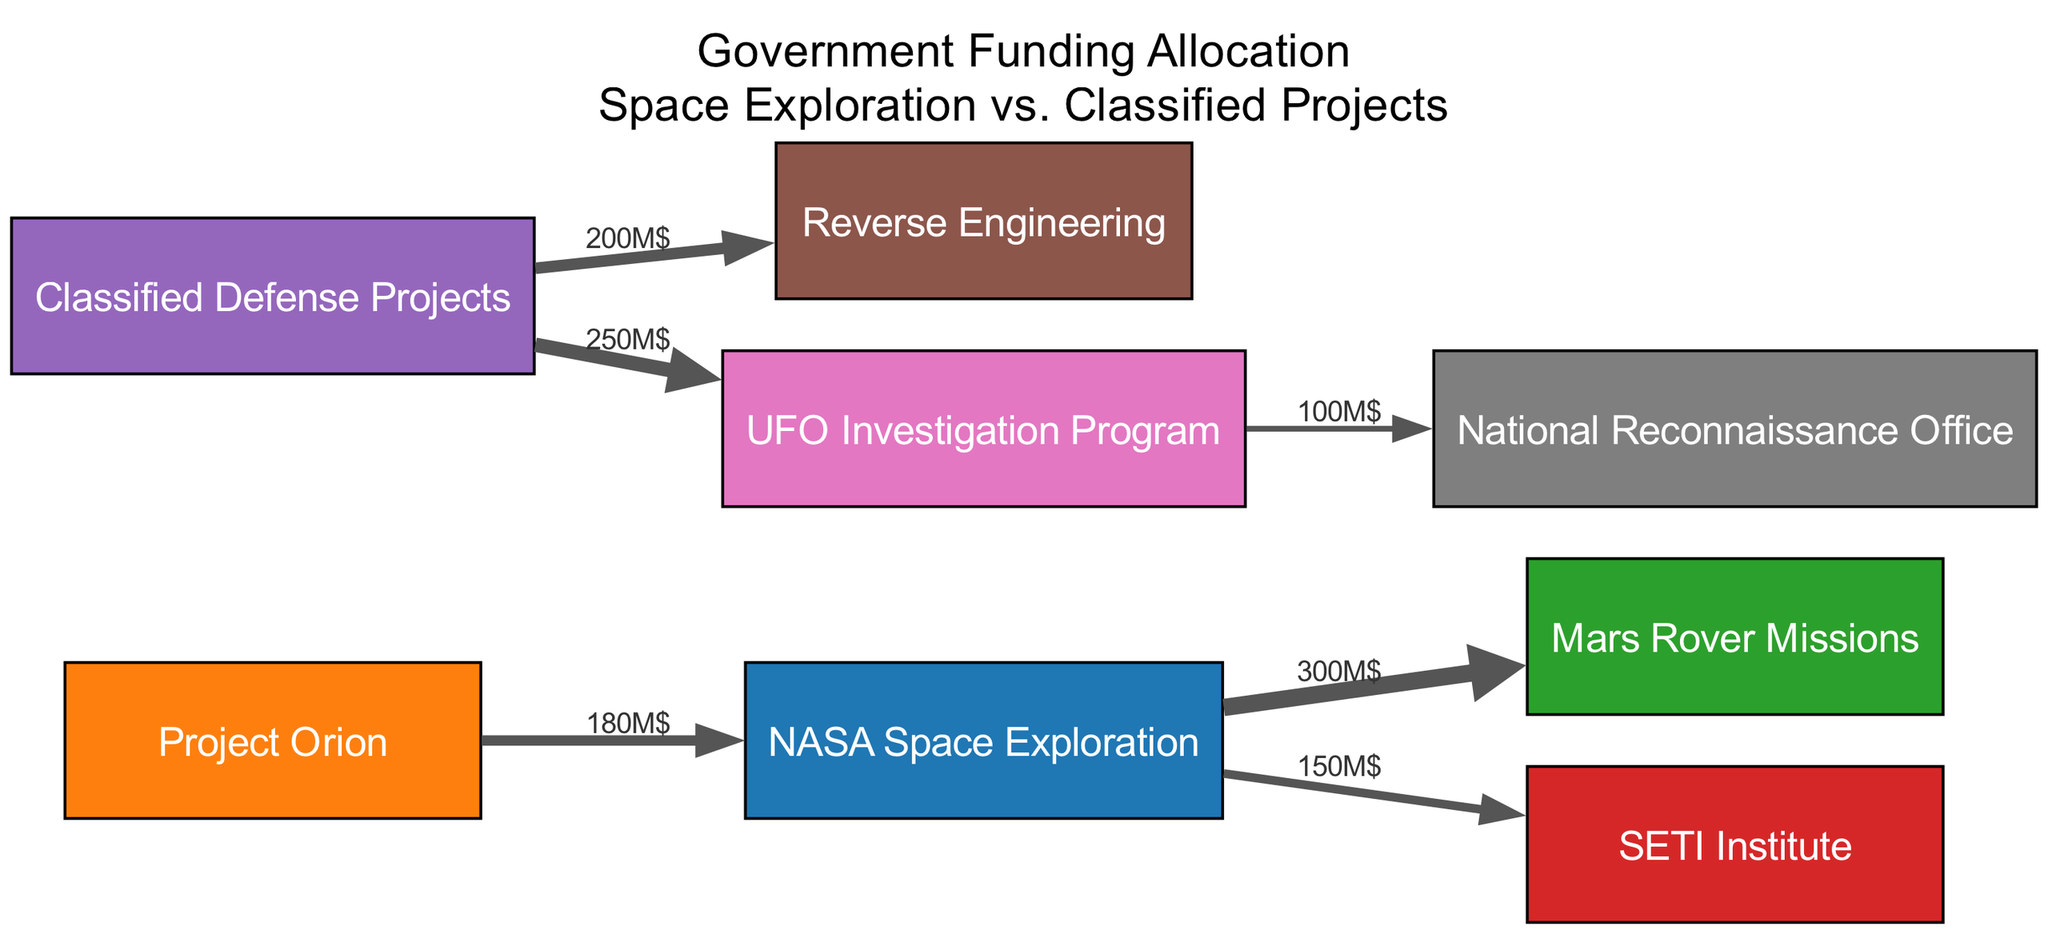What is the total funding allocated to NASA Space Exploration? By adding the values of the links directly connected to "NASA Space Exploration," which are 300M$ (Mars Rover Missions) and 150M$ (SETI Institute), we get 450M$ as the total funding.
Answer: 450M$ What is the value of funding directed towards the UFO Investigation Program? The direct link from "Classified Defense Projects" to the "UFO Investigation Program" shows a funding allocation of 250M$.
Answer: 250M$ How many nodes are present in the diagram? Counting the nodes listed: NASA Space Exploration, Project Orion, Mars Rover Missions, SETI Institute, Classified Defense Projects, Reverse Engineering, UFO Investigation Program, and National Reconnaissance Office gives a total of 8 nodes.
Answer: 8 Which project receives the least funding from the classified defense projects? Examining the links from "Classified Defense Projects," we see that "Reverse Engineering" receives 200M$ whereas "UFO Investigation Program" gets 250M$, therefore "Reverse Engineering" receives the least.
Answer: Reverse Engineering What proportion of total funding does the Mars Rover Missions account for in relation to the total funding directed towards space exploration? The total funding for space exploration is 450M$, and Mars Rover Missions receive 300M$. To find the proportion, divide 300M$ by 450M$, which gives approximately 66.67%.
Answer: 66.67% Which project has the highest outgoing funding from classified defense projects? Looking at the outgoing links from "Classified Defense Projects," the funding towards the "UFO Investigation Program" is 250M$, which is greater than the 200M$ allocated to "Reverse Engineering." Hence, "UFO Investigation Program" has the highest outgoing funding.
Answer: UFO Investigation Program What is the total outgoing funding from NASA Space Exploration for all projects? To determine the total outgoing funding from NASA Space Exploration, we sum the values: 300M$ (Mars Rover Missions) + 150M$ (SETI Institute) + 180M$ (Project Orion), which equals 630M$.
Answer: 630M$ How much funding does the National Reconnaissance Office receive from the UFO Investigation Program? The edge from "UFO Investigation Program" to "National Reconnaissance Office" shows a value of 100M$, indicating the amount received by the National Reconnaissance Office.
Answer: 100M$ 